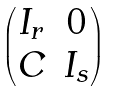<formula> <loc_0><loc_0><loc_500><loc_500>\begin{pmatrix} I _ { r } & 0 \\ C & I _ { s } \end{pmatrix}</formula> 